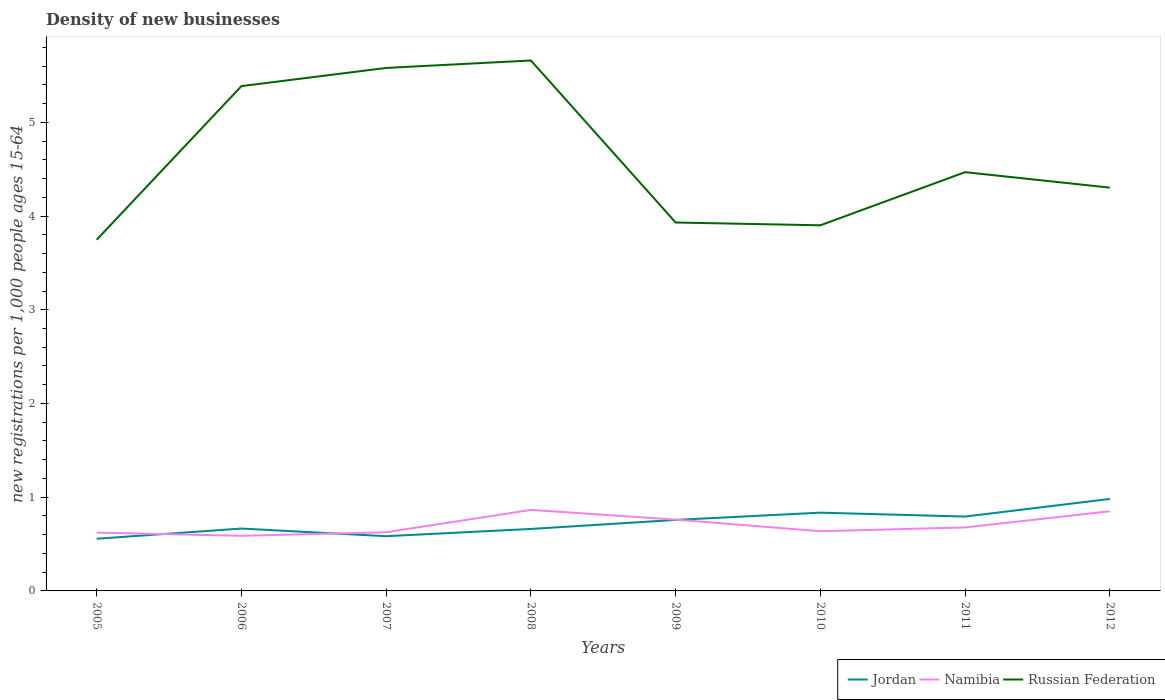Across all years, what is the maximum number of new registrations in Jordan?
Make the answer very short. 0.56. What is the total number of new registrations in Namibia in the graph?
Give a very brief answer. -0.05. What is the difference between the highest and the second highest number of new registrations in Russian Federation?
Offer a terse response. 1.91. Is the number of new registrations in Jordan strictly greater than the number of new registrations in Namibia over the years?
Give a very brief answer. No. How many lines are there?
Provide a short and direct response. 3. Are the values on the major ticks of Y-axis written in scientific E-notation?
Ensure brevity in your answer.  No. Does the graph contain any zero values?
Ensure brevity in your answer.  No. What is the title of the graph?
Give a very brief answer. Density of new businesses. What is the label or title of the Y-axis?
Your response must be concise. New registrations per 1,0 people ages 15-64. What is the new registrations per 1,000 people ages 15-64 of Jordan in 2005?
Your answer should be very brief. 0.56. What is the new registrations per 1,000 people ages 15-64 of Namibia in 2005?
Offer a terse response. 0.62. What is the new registrations per 1,000 people ages 15-64 of Russian Federation in 2005?
Provide a succinct answer. 3.75. What is the new registrations per 1,000 people ages 15-64 of Jordan in 2006?
Your answer should be very brief. 0.67. What is the new registrations per 1,000 people ages 15-64 of Namibia in 2006?
Make the answer very short. 0.59. What is the new registrations per 1,000 people ages 15-64 in Russian Federation in 2006?
Your response must be concise. 5.39. What is the new registrations per 1,000 people ages 15-64 of Jordan in 2007?
Your response must be concise. 0.58. What is the new registrations per 1,000 people ages 15-64 in Namibia in 2007?
Keep it short and to the point. 0.63. What is the new registrations per 1,000 people ages 15-64 in Russian Federation in 2007?
Your answer should be compact. 5.58. What is the new registrations per 1,000 people ages 15-64 in Jordan in 2008?
Provide a succinct answer. 0.66. What is the new registrations per 1,000 people ages 15-64 in Namibia in 2008?
Make the answer very short. 0.86. What is the new registrations per 1,000 people ages 15-64 of Russian Federation in 2008?
Ensure brevity in your answer.  5.66. What is the new registrations per 1,000 people ages 15-64 of Jordan in 2009?
Offer a very short reply. 0.76. What is the new registrations per 1,000 people ages 15-64 of Namibia in 2009?
Give a very brief answer. 0.76. What is the new registrations per 1,000 people ages 15-64 of Russian Federation in 2009?
Provide a succinct answer. 3.93. What is the new registrations per 1,000 people ages 15-64 in Jordan in 2010?
Ensure brevity in your answer.  0.84. What is the new registrations per 1,000 people ages 15-64 in Namibia in 2010?
Keep it short and to the point. 0.64. What is the new registrations per 1,000 people ages 15-64 of Russian Federation in 2010?
Your answer should be compact. 3.9. What is the new registrations per 1,000 people ages 15-64 of Jordan in 2011?
Make the answer very short. 0.79. What is the new registrations per 1,000 people ages 15-64 of Namibia in 2011?
Your response must be concise. 0.68. What is the new registrations per 1,000 people ages 15-64 of Russian Federation in 2011?
Keep it short and to the point. 4.47. What is the new registrations per 1,000 people ages 15-64 of Jordan in 2012?
Provide a succinct answer. 0.98. What is the new registrations per 1,000 people ages 15-64 of Russian Federation in 2012?
Provide a succinct answer. 4.3. Across all years, what is the maximum new registrations per 1,000 people ages 15-64 of Jordan?
Your answer should be very brief. 0.98. Across all years, what is the maximum new registrations per 1,000 people ages 15-64 in Namibia?
Keep it short and to the point. 0.86. Across all years, what is the maximum new registrations per 1,000 people ages 15-64 in Russian Federation?
Ensure brevity in your answer.  5.66. Across all years, what is the minimum new registrations per 1,000 people ages 15-64 of Jordan?
Keep it short and to the point. 0.56. Across all years, what is the minimum new registrations per 1,000 people ages 15-64 of Namibia?
Make the answer very short. 0.59. Across all years, what is the minimum new registrations per 1,000 people ages 15-64 in Russian Federation?
Make the answer very short. 3.75. What is the total new registrations per 1,000 people ages 15-64 in Jordan in the graph?
Provide a succinct answer. 5.83. What is the total new registrations per 1,000 people ages 15-64 of Namibia in the graph?
Offer a terse response. 5.63. What is the total new registrations per 1,000 people ages 15-64 of Russian Federation in the graph?
Make the answer very short. 36.98. What is the difference between the new registrations per 1,000 people ages 15-64 in Jordan in 2005 and that in 2006?
Provide a succinct answer. -0.11. What is the difference between the new registrations per 1,000 people ages 15-64 of Namibia in 2005 and that in 2006?
Keep it short and to the point. 0.03. What is the difference between the new registrations per 1,000 people ages 15-64 of Russian Federation in 2005 and that in 2006?
Make the answer very short. -1.64. What is the difference between the new registrations per 1,000 people ages 15-64 of Jordan in 2005 and that in 2007?
Provide a short and direct response. -0.03. What is the difference between the new registrations per 1,000 people ages 15-64 of Namibia in 2005 and that in 2007?
Offer a terse response. -0. What is the difference between the new registrations per 1,000 people ages 15-64 of Russian Federation in 2005 and that in 2007?
Your answer should be very brief. -1.83. What is the difference between the new registrations per 1,000 people ages 15-64 of Jordan in 2005 and that in 2008?
Make the answer very short. -0.1. What is the difference between the new registrations per 1,000 people ages 15-64 in Namibia in 2005 and that in 2008?
Provide a short and direct response. -0.24. What is the difference between the new registrations per 1,000 people ages 15-64 of Russian Federation in 2005 and that in 2008?
Your answer should be very brief. -1.91. What is the difference between the new registrations per 1,000 people ages 15-64 in Jordan in 2005 and that in 2009?
Offer a very short reply. -0.2. What is the difference between the new registrations per 1,000 people ages 15-64 in Namibia in 2005 and that in 2009?
Offer a very short reply. -0.14. What is the difference between the new registrations per 1,000 people ages 15-64 in Russian Federation in 2005 and that in 2009?
Give a very brief answer. -0.18. What is the difference between the new registrations per 1,000 people ages 15-64 in Jordan in 2005 and that in 2010?
Give a very brief answer. -0.28. What is the difference between the new registrations per 1,000 people ages 15-64 of Namibia in 2005 and that in 2010?
Provide a short and direct response. -0.01. What is the difference between the new registrations per 1,000 people ages 15-64 of Russian Federation in 2005 and that in 2010?
Provide a short and direct response. -0.15. What is the difference between the new registrations per 1,000 people ages 15-64 in Jordan in 2005 and that in 2011?
Give a very brief answer. -0.24. What is the difference between the new registrations per 1,000 people ages 15-64 of Namibia in 2005 and that in 2011?
Give a very brief answer. -0.06. What is the difference between the new registrations per 1,000 people ages 15-64 of Russian Federation in 2005 and that in 2011?
Your response must be concise. -0.72. What is the difference between the new registrations per 1,000 people ages 15-64 of Jordan in 2005 and that in 2012?
Provide a short and direct response. -0.42. What is the difference between the new registrations per 1,000 people ages 15-64 in Namibia in 2005 and that in 2012?
Offer a very short reply. -0.23. What is the difference between the new registrations per 1,000 people ages 15-64 of Russian Federation in 2005 and that in 2012?
Give a very brief answer. -0.56. What is the difference between the new registrations per 1,000 people ages 15-64 in Jordan in 2006 and that in 2007?
Your answer should be very brief. 0.08. What is the difference between the new registrations per 1,000 people ages 15-64 in Namibia in 2006 and that in 2007?
Your answer should be very brief. -0.04. What is the difference between the new registrations per 1,000 people ages 15-64 of Russian Federation in 2006 and that in 2007?
Your answer should be very brief. -0.19. What is the difference between the new registrations per 1,000 people ages 15-64 in Jordan in 2006 and that in 2008?
Provide a short and direct response. 0. What is the difference between the new registrations per 1,000 people ages 15-64 of Namibia in 2006 and that in 2008?
Offer a terse response. -0.28. What is the difference between the new registrations per 1,000 people ages 15-64 in Russian Federation in 2006 and that in 2008?
Ensure brevity in your answer.  -0.27. What is the difference between the new registrations per 1,000 people ages 15-64 in Jordan in 2006 and that in 2009?
Your response must be concise. -0.09. What is the difference between the new registrations per 1,000 people ages 15-64 of Namibia in 2006 and that in 2009?
Give a very brief answer. -0.17. What is the difference between the new registrations per 1,000 people ages 15-64 of Russian Federation in 2006 and that in 2009?
Offer a very short reply. 1.46. What is the difference between the new registrations per 1,000 people ages 15-64 in Jordan in 2006 and that in 2010?
Make the answer very short. -0.17. What is the difference between the new registrations per 1,000 people ages 15-64 of Namibia in 2006 and that in 2010?
Your answer should be very brief. -0.05. What is the difference between the new registrations per 1,000 people ages 15-64 in Russian Federation in 2006 and that in 2010?
Provide a short and direct response. 1.49. What is the difference between the new registrations per 1,000 people ages 15-64 in Jordan in 2006 and that in 2011?
Your answer should be very brief. -0.13. What is the difference between the new registrations per 1,000 people ages 15-64 in Namibia in 2006 and that in 2011?
Make the answer very short. -0.09. What is the difference between the new registrations per 1,000 people ages 15-64 in Russian Federation in 2006 and that in 2011?
Give a very brief answer. 0.92. What is the difference between the new registrations per 1,000 people ages 15-64 in Jordan in 2006 and that in 2012?
Make the answer very short. -0.32. What is the difference between the new registrations per 1,000 people ages 15-64 of Namibia in 2006 and that in 2012?
Give a very brief answer. -0.26. What is the difference between the new registrations per 1,000 people ages 15-64 of Russian Federation in 2006 and that in 2012?
Provide a short and direct response. 1.08. What is the difference between the new registrations per 1,000 people ages 15-64 in Jordan in 2007 and that in 2008?
Give a very brief answer. -0.08. What is the difference between the new registrations per 1,000 people ages 15-64 of Namibia in 2007 and that in 2008?
Make the answer very short. -0.24. What is the difference between the new registrations per 1,000 people ages 15-64 in Russian Federation in 2007 and that in 2008?
Offer a very short reply. -0.08. What is the difference between the new registrations per 1,000 people ages 15-64 of Jordan in 2007 and that in 2009?
Provide a succinct answer. -0.17. What is the difference between the new registrations per 1,000 people ages 15-64 in Namibia in 2007 and that in 2009?
Give a very brief answer. -0.13. What is the difference between the new registrations per 1,000 people ages 15-64 of Russian Federation in 2007 and that in 2009?
Make the answer very short. 1.65. What is the difference between the new registrations per 1,000 people ages 15-64 of Jordan in 2007 and that in 2010?
Provide a short and direct response. -0.25. What is the difference between the new registrations per 1,000 people ages 15-64 in Namibia in 2007 and that in 2010?
Give a very brief answer. -0.01. What is the difference between the new registrations per 1,000 people ages 15-64 in Russian Federation in 2007 and that in 2010?
Offer a terse response. 1.68. What is the difference between the new registrations per 1,000 people ages 15-64 of Jordan in 2007 and that in 2011?
Ensure brevity in your answer.  -0.21. What is the difference between the new registrations per 1,000 people ages 15-64 of Namibia in 2007 and that in 2011?
Provide a succinct answer. -0.05. What is the difference between the new registrations per 1,000 people ages 15-64 in Russian Federation in 2007 and that in 2011?
Your answer should be compact. 1.11. What is the difference between the new registrations per 1,000 people ages 15-64 of Jordan in 2007 and that in 2012?
Give a very brief answer. -0.4. What is the difference between the new registrations per 1,000 people ages 15-64 of Namibia in 2007 and that in 2012?
Offer a very short reply. -0.22. What is the difference between the new registrations per 1,000 people ages 15-64 of Russian Federation in 2007 and that in 2012?
Your answer should be very brief. 1.28. What is the difference between the new registrations per 1,000 people ages 15-64 of Jordan in 2008 and that in 2009?
Keep it short and to the point. -0.1. What is the difference between the new registrations per 1,000 people ages 15-64 of Namibia in 2008 and that in 2009?
Keep it short and to the point. 0.1. What is the difference between the new registrations per 1,000 people ages 15-64 in Russian Federation in 2008 and that in 2009?
Your answer should be compact. 1.73. What is the difference between the new registrations per 1,000 people ages 15-64 in Jordan in 2008 and that in 2010?
Offer a very short reply. -0.17. What is the difference between the new registrations per 1,000 people ages 15-64 in Namibia in 2008 and that in 2010?
Make the answer very short. 0.23. What is the difference between the new registrations per 1,000 people ages 15-64 of Russian Federation in 2008 and that in 2010?
Provide a short and direct response. 1.76. What is the difference between the new registrations per 1,000 people ages 15-64 in Jordan in 2008 and that in 2011?
Ensure brevity in your answer.  -0.13. What is the difference between the new registrations per 1,000 people ages 15-64 in Namibia in 2008 and that in 2011?
Ensure brevity in your answer.  0.19. What is the difference between the new registrations per 1,000 people ages 15-64 of Russian Federation in 2008 and that in 2011?
Provide a short and direct response. 1.19. What is the difference between the new registrations per 1,000 people ages 15-64 in Jordan in 2008 and that in 2012?
Offer a very short reply. -0.32. What is the difference between the new registrations per 1,000 people ages 15-64 in Namibia in 2008 and that in 2012?
Offer a terse response. 0.01. What is the difference between the new registrations per 1,000 people ages 15-64 in Russian Federation in 2008 and that in 2012?
Offer a terse response. 1.36. What is the difference between the new registrations per 1,000 people ages 15-64 in Jordan in 2009 and that in 2010?
Provide a short and direct response. -0.08. What is the difference between the new registrations per 1,000 people ages 15-64 in Namibia in 2009 and that in 2010?
Keep it short and to the point. 0.12. What is the difference between the new registrations per 1,000 people ages 15-64 in Russian Federation in 2009 and that in 2010?
Make the answer very short. 0.03. What is the difference between the new registrations per 1,000 people ages 15-64 of Jordan in 2009 and that in 2011?
Offer a terse response. -0.04. What is the difference between the new registrations per 1,000 people ages 15-64 in Namibia in 2009 and that in 2011?
Your answer should be compact. 0.08. What is the difference between the new registrations per 1,000 people ages 15-64 of Russian Federation in 2009 and that in 2011?
Ensure brevity in your answer.  -0.54. What is the difference between the new registrations per 1,000 people ages 15-64 of Jordan in 2009 and that in 2012?
Give a very brief answer. -0.22. What is the difference between the new registrations per 1,000 people ages 15-64 in Namibia in 2009 and that in 2012?
Provide a succinct answer. -0.09. What is the difference between the new registrations per 1,000 people ages 15-64 in Russian Federation in 2009 and that in 2012?
Your answer should be very brief. -0.37. What is the difference between the new registrations per 1,000 people ages 15-64 in Jordan in 2010 and that in 2011?
Give a very brief answer. 0.04. What is the difference between the new registrations per 1,000 people ages 15-64 of Namibia in 2010 and that in 2011?
Your answer should be compact. -0.04. What is the difference between the new registrations per 1,000 people ages 15-64 in Russian Federation in 2010 and that in 2011?
Ensure brevity in your answer.  -0.57. What is the difference between the new registrations per 1,000 people ages 15-64 in Jordan in 2010 and that in 2012?
Ensure brevity in your answer.  -0.15. What is the difference between the new registrations per 1,000 people ages 15-64 of Namibia in 2010 and that in 2012?
Offer a terse response. -0.21. What is the difference between the new registrations per 1,000 people ages 15-64 in Russian Federation in 2010 and that in 2012?
Give a very brief answer. -0.4. What is the difference between the new registrations per 1,000 people ages 15-64 of Jordan in 2011 and that in 2012?
Give a very brief answer. -0.19. What is the difference between the new registrations per 1,000 people ages 15-64 in Namibia in 2011 and that in 2012?
Make the answer very short. -0.17. What is the difference between the new registrations per 1,000 people ages 15-64 in Russian Federation in 2011 and that in 2012?
Make the answer very short. 0.17. What is the difference between the new registrations per 1,000 people ages 15-64 in Jordan in 2005 and the new registrations per 1,000 people ages 15-64 in Namibia in 2006?
Give a very brief answer. -0.03. What is the difference between the new registrations per 1,000 people ages 15-64 in Jordan in 2005 and the new registrations per 1,000 people ages 15-64 in Russian Federation in 2006?
Ensure brevity in your answer.  -4.83. What is the difference between the new registrations per 1,000 people ages 15-64 of Namibia in 2005 and the new registrations per 1,000 people ages 15-64 of Russian Federation in 2006?
Offer a terse response. -4.76. What is the difference between the new registrations per 1,000 people ages 15-64 in Jordan in 2005 and the new registrations per 1,000 people ages 15-64 in Namibia in 2007?
Your answer should be compact. -0.07. What is the difference between the new registrations per 1,000 people ages 15-64 of Jordan in 2005 and the new registrations per 1,000 people ages 15-64 of Russian Federation in 2007?
Your response must be concise. -5.02. What is the difference between the new registrations per 1,000 people ages 15-64 of Namibia in 2005 and the new registrations per 1,000 people ages 15-64 of Russian Federation in 2007?
Provide a short and direct response. -4.96. What is the difference between the new registrations per 1,000 people ages 15-64 of Jordan in 2005 and the new registrations per 1,000 people ages 15-64 of Namibia in 2008?
Keep it short and to the point. -0.31. What is the difference between the new registrations per 1,000 people ages 15-64 in Jordan in 2005 and the new registrations per 1,000 people ages 15-64 in Russian Federation in 2008?
Provide a succinct answer. -5.1. What is the difference between the new registrations per 1,000 people ages 15-64 of Namibia in 2005 and the new registrations per 1,000 people ages 15-64 of Russian Federation in 2008?
Provide a succinct answer. -5.04. What is the difference between the new registrations per 1,000 people ages 15-64 in Jordan in 2005 and the new registrations per 1,000 people ages 15-64 in Namibia in 2009?
Your response must be concise. -0.2. What is the difference between the new registrations per 1,000 people ages 15-64 of Jordan in 2005 and the new registrations per 1,000 people ages 15-64 of Russian Federation in 2009?
Keep it short and to the point. -3.37. What is the difference between the new registrations per 1,000 people ages 15-64 of Namibia in 2005 and the new registrations per 1,000 people ages 15-64 of Russian Federation in 2009?
Keep it short and to the point. -3.31. What is the difference between the new registrations per 1,000 people ages 15-64 of Jordan in 2005 and the new registrations per 1,000 people ages 15-64 of Namibia in 2010?
Keep it short and to the point. -0.08. What is the difference between the new registrations per 1,000 people ages 15-64 of Jordan in 2005 and the new registrations per 1,000 people ages 15-64 of Russian Federation in 2010?
Keep it short and to the point. -3.34. What is the difference between the new registrations per 1,000 people ages 15-64 in Namibia in 2005 and the new registrations per 1,000 people ages 15-64 in Russian Federation in 2010?
Give a very brief answer. -3.28. What is the difference between the new registrations per 1,000 people ages 15-64 of Jordan in 2005 and the new registrations per 1,000 people ages 15-64 of Namibia in 2011?
Your answer should be compact. -0.12. What is the difference between the new registrations per 1,000 people ages 15-64 in Jordan in 2005 and the new registrations per 1,000 people ages 15-64 in Russian Federation in 2011?
Offer a very short reply. -3.91. What is the difference between the new registrations per 1,000 people ages 15-64 in Namibia in 2005 and the new registrations per 1,000 people ages 15-64 in Russian Federation in 2011?
Give a very brief answer. -3.85. What is the difference between the new registrations per 1,000 people ages 15-64 of Jordan in 2005 and the new registrations per 1,000 people ages 15-64 of Namibia in 2012?
Offer a terse response. -0.29. What is the difference between the new registrations per 1,000 people ages 15-64 in Jordan in 2005 and the new registrations per 1,000 people ages 15-64 in Russian Federation in 2012?
Offer a terse response. -3.75. What is the difference between the new registrations per 1,000 people ages 15-64 in Namibia in 2005 and the new registrations per 1,000 people ages 15-64 in Russian Federation in 2012?
Give a very brief answer. -3.68. What is the difference between the new registrations per 1,000 people ages 15-64 of Jordan in 2006 and the new registrations per 1,000 people ages 15-64 of Namibia in 2007?
Your answer should be very brief. 0.04. What is the difference between the new registrations per 1,000 people ages 15-64 of Jordan in 2006 and the new registrations per 1,000 people ages 15-64 of Russian Federation in 2007?
Ensure brevity in your answer.  -4.91. What is the difference between the new registrations per 1,000 people ages 15-64 of Namibia in 2006 and the new registrations per 1,000 people ages 15-64 of Russian Federation in 2007?
Provide a short and direct response. -4.99. What is the difference between the new registrations per 1,000 people ages 15-64 in Jordan in 2006 and the new registrations per 1,000 people ages 15-64 in Namibia in 2008?
Provide a short and direct response. -0.2. What is the difference between the new registrations per 1,000 people ages 15-64 in Jordan in 2006 and the new registrations per 1,000 people ages 15-64 in Russian Federation in 2008?
Offer a terse response. -4.99. What is the difference between the new registrations per 1,000 people ages 15-64 in Namibia in 2006 and the new registrations per 1,000 people ages 15-64 in Russian Federation in 2008?
Ensure brevity in your answer.  -5.07. What is the difference between the new registrations per 1,000 people ages 15-64 in Jordan in 2006 and the new registrations per 1,000 people ages 15-64 in Namibia in 2009?
Your answer should be compact. -0.1. What is the difference between the new registrations per 1,000 people ages 15-64 of Jordan in 2006 and the new registrations per 1,000 people ages 15-64 of Russian Federation in 2009?
Offer a terse response. -3.27. What is the difference between the new registrations per 1,000 people ages 15-64 of Namibia in 2006 and the new registrations per 1,000 people ages 15-64 of Russian Federation in 2009?
Provide a succinct answer. -3.34. What is the difference between the new registrations per 1,000 people ages 15-64 in Jordan in 2006 and the new registrations per 1,000 people ages 15-64 in Namibia in 2010?
Provide a succinct answer. 0.03. What is the difference between the new registrations per 1,000 people ages 15-64 of Jordan in 2006 and the new registrations per 1,000 people ages 15-64 of Russian Federation in 2010?
Ensure brevity in your answer.  -3.24. What is the difference between the new registrations per 1,000 people ages 15-64 of Namibia in 2006 and the new registrations per 1,000 people ages 15-64 of Russian Federation in 2010?
Keep it short and to the point. -3.31. What is the difference between the new registrations per 1,000 people ages 15-64 in Jordan in 2006 and the new registrations per 1,000 people ages 15-64 in Namibia in 2011?
Keep it short and to the point. -0.01. What is the difference between the new registrations per 1,000 people ages 15-64 in Jordan in 2006 and the new registrations per 1,000 people ages 15-64 in Russian Federation in 2011?
Your answer should be very brief. -3.8. What is the difference between the new registrations per 1,000 people ages 15-64 in Namibia in 2006 and the new registrations per 1,000 people ages 15-64 in Russian Federation in 2011?
Ensure brevity in your answer.  -3.88. What is the difference between the new registrations per 1,000 people ages 15-64 in Jordan in 2006 and the new registrations per 1,000 people ages 15-64 in Namibia in 2012?
Provide a short and direct response. -0.18. What is the difference between the new registrations per 1,000 people ages 15-64 of Jordan in 2006 and the new registrations per 1,000 people ages 15-64 of Russian Federation in 2012?
Your answer should be compact. -3.64. What is the difference between the new registrations per 1,000 people ages 15-64 of Namibia in 2006 and the new registrations per 1,000 people ages 15-64 of Russian Federation in 2012?
Provide a short and direct response. -3.71. What is the difference between the new registrations per 1,000 people ages 15-64 of Jordan in 2007 and the new registrations per 1,000 people ages 15-64 of Namibia in 2008?
Offer a terse response. -0.28. What is the difference between the new registrations per 1,000 people ages 15-64 of Jordan in 2007 and the new registrations per 1,000 people ages 15-64 of Russian Federation in 2008?
Make the answer very short. -5.08. What is the difference between the new registrations per 1,000 people ages 15-64 in Namibia in 2007 and the new registrations per 1,000 people ages 15-64 in Russian Federation in 2008?
Keep it short and to the point. -5.03. What is the difference between the new registrations per 1,000 people ages 15-64 of Jordan in 2007 and the new registrations per 1,000 people ages 15-64 of Namibia in 2009?
Give a very brief answer. -0.18. What is the difference between the new registrations per 1,000 people ages 15-64 in Jordan in 2007 and the new registrations per 1,000 people ages 15-64 in Russian Federation in 2009?
Offer a terse response. -3.35. What is the difference between the new registrations per 1,000 people ages 15-64 in Namibia in 2007 and the new registrations per 1,000 people ages 15-64 in Russian Federation in 2009?
Offer a very short reply. -3.3. What is the difference between the new registrations per 1,000 people ages 15-64 of Jordan in 2007 and the new registrations per 1,000 people ages 15-64 of Namibia in 2010?
Offer a very short reply. -0.05. What is the difference between the new registrations per 1,000 people ages 15-64 of Jordan in 2007 and the new registrations per 1,000 people ages 15-64 of Russian Federation in 2010?
Keep it short and to the point. -3.32. What is the difference between the new registrations per 1,000 people ages 15-64 of Namibia in 2007 and the new registrations per 1,000 people ages 15-64 of Russian Federation in 2010?
Provide a short and direct response. -3.27. What is the difference between the new registrations per 1,000 people ages 15-64 of Jordan in 2007 and the new registrations per 1,000 people ages 15-64 of Namibia in 2011?
Offer a terse response. -0.09. What is the difference between the new registrations per 1,000 people ages 15-64 in Jordan in 2007 and the new registrations per 1,000 people ages 15-64 in Russian Federation in 2011?
Offer a terse response. -3.88. What is the difference between the new registrations per 1,000 people ages 15-64 of Namibia in 2007 and the new registrations per 1,000 people ages 15-64 of Russian Federation in 2011?
Your answer should be compact. -3.84. What is the difference between the new registrations per 1,000 people ages 15-64 in Jordan in 2007 and the new registrations per 1,000 people ages 15-64 in Namibia in 2012?
Offer a terse response. -0.27. What is the difference between the new registrations per 1,000 people ages 15-64 in Jordan in 2007 and the new registrations per 1,000 people ages 15-64 in Russian Federation in 2012?
Ensure brevity in your answer.  -3.72. What is the difference between the new registrations per 1,000 people ages 15-64 of Namibia in 2007 and the new registrations per 1,000 people ages 15-64 of Russian Federation in 2012?
Ensure brevity in your answer.  -3.68. What is the difference between the new registrations per 1,000 people ages 15-64 in Jordan in 2008 and the new registrations per 1,000 people ages 15-64 in Namibia in 2009?
Give a very brief answer. -0.1. What is the difference between the new registrations per 1,000 people ages 15-64 of Jordan in 2008 and the new registrations per 1,000 people ages 15-64 of Russian Federation in 2009?
Keep it short and to the point. -3.27. What is the difference between the new registrations per 1,000 people ages 15-64 in Namibia in 2008 and the new registrations per 1,000 people ages 15-64 in Russian Federation in 2009?
Provide a short and direct response. -3.07. What is the difference between the new registrations per 1,000 people ages 15-64 in Jordan in 2008 and the new registrations per 1,000 people ages 15-64 in Namibia in 2010?
Ensure brevity in your answer.  0.02. What is the difference between the new registrations per 1,000 people ages 15-64 in Jordan in 2008 and the new registrations per 1,000 people ages 15-64 in Russian Federation in 2010?
Make the answer very short. -3.24. What is the difference between the new registrations per 1,000 people ages 15-64 of Namibia in 2008 and the new registrations per 1,000 people ages 15-64 of Russian Federation in 2010?
Offer a very short reply. -3.04. What is the difference between the new registrations per 1,000 people ages 15-64 in Jordan in 2008 and the new registrations per 1,000 people ages 15-64 in Namibia in 2011?
Ensure brevity in your answer.  -0.02. What is the difference between the new registrations per 1,000 people ages 15-64 of Jordan in 2008 and the new registrations per 1,000 people ages 15-64 of Russian Federation in 2011?
Offer a terse response. -3.81. What is the difference between the new registrations per 1,000 people ages 15-64 of Namibia in 2008 and the new registrations per 1,000 people ages 15-64 of Russian Federation in 2011?
Give a very brief answer. -3.6. What is the difference between the new registrations per 1,000 people ages 15-64 of Jordan in 2008 and the new registrations per 1,000 people ages 15-64 of Namibia in 2012?
Keep it short and to the point. -0.19. What is the difference between the new registrations per 1,000 people ages 15-64 in Jordan in 2008 and the new registrations per 1,000 people ages 15-64 in Russian Federation in 2012?
Make the answer very short. -3.64. What is the difference between the new registrations per 1,000 people ages 15-64 of Namibia in 2008 and the new registrations per 1,000 people ages 15-64 of Russian Federation in 2012?
Your answer should be compact. -3.44. What is the difference between the new registrations per 1,000 people ages 15-64 of Jordan in 2009 and the new registrations per 1,000 people ages 15-64 of Namibia in 2010?
Your response must be concise. 0.12. What is the difference between the new registrations per 1,000 people ages 15-64 in Jordan in 2009 and the new registrations per 1,000 people ages 15-64 in Russian Federation in 2010?
Ensure brevity in your answer.  -3.14. What is the difference between the new registrations per 1,000 people ages 15-64 of Namibia in 2009 and the new registrations per 1,000 people ages 15-64 of Russian Federation in 2010?
Give a very brief answer. -3.14. What is the difference between the new registrations per 1,000 people ages 15-64 in Jordan in 2009 and the new registrations per 1,000 people ages 15-64 in Namibia in 2011?
Make the answer very short. 0.08. What is the difference between the new registrations per 1,000 people ages 15-64 of Jordan in 2009 and the new registrations per 1,000 people ages 15-64 of Russian Federation in 2011?
Your answer should be compact. -3.71. What is the difference between the new registrations per 1,000 people ages 15-64 of Namibia in 2009 and the new registrations per 1,000 people ages 15-64 of Russian Federation in 2011?
Make the answer very short. -3.71. What is the difference between the new registrations per 1,000 people ages 15-64 in Jordan in 2009 and the new registrations per 1,000 people ages 15-64 in Namibia in 2012?
Keep it short and to the point. -0.09. What is the difference between the new registrations per 1,000 people ages 15-64 in Jordan in 2009 and the new registrations per 1,000 people ages 15-64 in Russian Federation in 2012?
Offer a very short reply. -3.55. What is the difference between the new registrations per 1,000 people ages 15-64 of Namibia in 2009 and the new registrations per 1,000 people ages 15-64 of Russian Federation in 2012?
Offer a terse response. -3.54. What is the difference between the new registrations per 1,000 people ages 15-64 in Jordan in 2010 and the new registrations per 1,000 people ages 15-64 in Namibia in 2011?
Provide a short and direct response. 0.16. What is the difference between the new registrations per 1,000 people ages 15-64 of Jordan in 2010 and the new registrations per 1,000 people ages 15-64 of Russian Federation in 2011?
Make the answer very short. -3.63. What is the difference between the new registrations per 1,000 people ages 15-64 in Namibia in 2010 and the new registrations per 1,000 people ages 15-64 in Russian Federation in 2011?
Your response must be concise. -3.83. What is the difference between the new registrations per 1,000 people ages 15-64 in Jordan in 2010 and the new registrations per 1,000 people ages 15-64 in Namibia in 2012?
Offer a very short reply. -0.01. What is the difference between the new registrations per 1,000 people ages 15-64 of Jordan in 2010 and the new registrations per 1,000 people ages 15-64 of Russian Federation in 2012?
Ensure brevity in your answer.  -3.47. What is the difference between the new registrations per 1,000 people ages 15-64 of Namibia in 2010 and the new registrations per 1,000 people ages 15-64 of Russian Federation in 2012?
Your answer should be compact. -3.67. What is the difference between the new registrations per 1,000 people ages 15-64 in Jordan in 2011 and the new registrations per 1,000 people ages 15-64 in Namibia in 2012?
Ensure brevity in your answer.  -0.06. What is the difference between the new registrations per 1,000 people ages 15-64 of Jordan in 2011 and the new registrations per 1,000 people ages 15-64 of Russian Federation in 2012?
Your response must be concise. -3.51. What is the difference between the new registrations per 1,000 people ages 15-64 of Namibia in 2011 and the new registrations per 1,000 people ages 15-64 of Russian Federation in 2012?
Give a very brief answer. -3.63. What is the average new registrations per 1,000 people ages 15-64 in Jordan per year?
Offer a terse response. 0.73. What is the average new registrations per 1,000 people ages 15-64 in Namibia per year?
Your response must be concise. 0.7. What is the average new registrations per 1,000 people ages 15-64 of Russian Federation per year?
Your answer should be very brief. 4.62. In the year 2005, what is the difference between the new registrations per 1,000 people ages 15-64 in Jordan and new registrations per 1,000 people ages 15-64 in Namibia?
Make the answer very short. -0.07. In the year 2005, what is the difference between the new registrations per 1,000 people ages 15-64 of Jordan and new registrations per 1,000 people ages 15-64 of Russian Federation?
Keep it short and to the point. -3.19. In the year 2005, what is the difference between the new registrations per 1,000 people ages 15-64 in Namibia and new registrations per 1,000 people ages 15-64 in Russian Federation?
Ensure brevity in your answer.  -3.13. In the year 2006, what is the difference between the new registrations per 1,000 people ages 15-64 in Jordan and new registrations per 1,000 people ages 15-64 in Namibia?
Offer a very short reply. 0.08. In the year 2006, what is the difference between the new registrations per 1,000 people ages 15-64 in Jordan and new registrations per 1,000 people ages 15-64 in Russian Federation?
Your answer should be very brief. -4.72. In the year 2006, what is the difference between the new registrations per 1,000 people ages 15-64 in Namibia and new registrations per 1,000 people ages 15-64 in Russian Federation?
Provide a succinct answer. -4.8. In the year 2007, what is the difference between the new registrations per 1,000 people ages 15-64 of Jordan and new registrations per 1,000 people ages 15-64 of Namibia?
Provide a succinct answer. -0.04. In the year 2007, what is the difference between the new registrations per 1,000 people ages 15-64 in Jordan and new registrations per 1,000 people ages 15-64 in Russian Federation?
Offer a very short reply. -5. In the year 2007, what is the difference between the new registrations per 1,000 people ages 15-64 in Namibia and new registrations per 1,000 people ages 15-64 in Russian Federation?
Provide a short and direct response. -4.95. In the year 2008, what is the difference between the new registrations per 1,000 people ages 15-64 of Jordan and new registrations per 1,000 people ages 15-64 of Namibia?
Keep it short and to the point. -0.2. In the year 2008, what is the difference between the new registrations per 1,000 people ages 15-64 in Jordan and new registrations per 1,000 people ages 15-64 in Russian Federation?
Your answer should be very brief. -5. In the year 2008, what is the difference between the new registrations per 1,000 people ages 15-64 of Namibia and new registrations per 1,000 people ages 15-64 of Russian Federation?
Provide a succinct answer. -4.79. In the year 2009, what is the difference between the new registrations per 1,000 people ages 15-64 in Jordan and new registrations per 1,000 people ages 15-64 in Namibia?
Your response must be concise. -0. In the year 2009, what is the difference between the new registrations per 1,000 people ages 15-64 in Jordan and new registrations per 1,000 people ages 15-64 in Russian Federation?
Offer a very short reply. -3.17. In the year 2009, what is the difference between the new registrations per 1,000 people ages 15-64 of Namibia and new registrations per 1,000 people ages 15-64 of Russian Federation?
Your answer should be very brief. -3.17. In the year 2010, what is the difference between the new registrations per 1,000 people ages 15-64 of Jordan and new registrations per 1,000 people ages 15-64 of Namibia?
Provide a succinct answer. 0.2. In the year 2010, what is the difference between the new registrations per 1,000 people ages 15-64 in Jordan and new registrations per 1,000 people ages 15-64 in Russian Federation?
Offer a terse response. -3.07. In the year 2010, what is the difference between the new registrations per 1,000 people ages 15-64 of Namibia and new registrations per 1,000 people ages 15-64 of Russian Federation?
Make the answer very short. -3.26. In the year 2011, what is the difference between the new registrations per 1,000 people ages 15-64 in Jordan and new registrations per 1,000 people ages 15-64 in Namibia?
Offer a terse response. 0.12. In the year 2011, what is the difference between the new registrations per 1,000 people ages 15-64 in Jordan and new registrations per 1,000 people ages 15-64 in Russian Federation?
Your response must be concise. -3.67. In the year 2011, what is the difference between the new registrations per 1,000 people ages 15-64 of Namibia and new registrations per 1,000 people ages 15-64 of Russian Federation?
Provide a succinct answer. -3.79. In the year 2012, what is the difference between the new registrations per 1,000 people ages 15-64 of Jordan and new registrations per 1,000 people ages 15-64 of Namibia?
Your answer should be very brief. 0.13. In the year 2012, what is the difference between the new registrations per 1,000 people ages 15-64 in Jordan and new registrations per 1,000 people ages 15-64 in Russian Federation?
Provide a short and direct response. -3.32. In the year 2012, what is the difference between the new registrations per 1,000 people ages 15-64 in Namibia and new registrations per 1,000 people ages 15-64 in Russian Federation?
Your response must be concise. -3.45. What is the ratio of the new registrations per 1,000 people ages 15-64 of Jordan in 2005 to that in 2006?
Your answer should be compact. 0.84. What is the ratio of the new registrations per 1,000 people ages 15-64 in Namibia in 2005 to that in 2006?
Keep it short and to the point. 1.06. What is the ratio of the new registrations per 1,000 people ages 15-64 of Russian Federation in 2005 to that in 2006?
Give a very brief answer. 0.7. What is the ratio of the new registrations per 1,000 people ages 15-64 in Jordan in 2005 to that in 2007?
Provide a succinct answer. 0.95. What is the ratio of the new registrations per 1,000 people ages 15-64 of Namibia in 2005 to that in 2007?
Offer a terse response. 0.99. What is the ratio of the new registrations per 1,000 people ages 15-64 of Russian Federation in 2005 to that in 2007?
Offer a very short reply. 0.67. What is the ratio of the new registrations per 1,000 people ages 15-64 of Jordan in 2005 to that in 2008?
Keep it short and to the point. 0.84. What is the ratio of the new registrations per 1,000 people ages 15-64 of Namibia in 2005 to that in 2008?
Provide a succinct answer. 0.72. What is the ratio of the new registrations per 1,000 people ages 15-64 in Russian Federation in 2005 to that in 2008?
Offer a very short reply. 0.66. What is the ratio of the new registrations per 1,000 people ages 15-64 of Jordan in 2005 to that in 2009?
Give a very brief answer. 0.73. What is the ratio of the new registrations per 1,000 people ages 15-64 of Namibia in 2005 to that in 2009?
Offer a very short reply. 0.82. What is the ratio of the new registrations per 1,000 people ages 15-64 in Russian Federation in 2005 to that in 2009?
Offer a very short reply. 0.95. What is the ratio of the new registrations per 1,000 people ages 15-64 in Namibia in 2005 to that in 2010?
Provide a succinct answer. 0.98. What is the ratio of the new registrations per 1,000 people ages 15-64 of Russian Federation in 2005 to that in 2010?
Provide a succinct answer. 0.96. What is the ratio of the new registrations per 1,000 people ages 15-64 of Jordan in 2005 to that in 2011?
Offer a terse response. 0.7. What is the ratio of the new registrations per 1,000 people ages 15-64 of Namibia in 2005 to that in 2011?
Your response must be concise. 0.92. What is the ratio of the new registrations per 1,000 people ages 15-64 in Russian Federation in 2005 to that in 2011?
Your response must be concise. 0.84. What is the ratio of the new registrations per 1,000 people ages 15-64 of Jordan in 2005 to that in 2012?
Your answer should be compact. 0.57. What is the ratio of the new registrations per 1,000 people ages 15-64 of Namibia in 2005 to that in 2012?
Make the answer very short. 0.73. What is the ratio of the new registrations per 1,000 people ages 15-64 of Russian Federation in 2005 to that in 2012?
Give a very brief answer. 0.87. What is the ratio of the new registrations per 1,000 people ages 15-64 in Jordan in 2006 to that in 2007?
Your response must be concise. 1.14. What is the ratio of the new registrations per 1,000 people ages 15-64 of Namibia in 2006 to that in 2007?
Offer a very short reply. 0.94. What is the ratio of the new registrations per 1,000 people ages 15-64 in Russian Federation in 2006 to that in 2007?
Keep it short and to the point. 0.97. What is the ratio of the new registrations per 1,000 people ages 15-64 of Jordan in 2006 to that in 2008?
Your response must be concise. 1.01. What is the ratio of the new registrations per 1,000 people ages 15-64 in Namibia in 2006 to that in 2008?
Offer a terse response. 0.68. What is the ratio of the new registrations per 1,000 people ages 15-64 in Russian Federation in 2006 to that in 2008?
Make the answer very short. 0.95. What is the ratio of the new registrations per 1,000 people ages 15-64 in Jordan in 2006 to that in 2009?
Your answer should be compact. 0.88. What is the ratio of the new registrations per 1,000 people ages 15-64 in Namibia in 2006 to that in 2009?
Your response must be concise. 0.77. What is the ratio of the new registrations per 1,000 people ages 15-64 of Russian Federation in 2006 to that in 2009?
Provide a short and direct response. 1.37. What is the ratio of the new registrations per 1,000 people ages 15-64 of Jordan in 2006 to that in 2010?
Your answer should be compact. 0.8. What is the ratio of the new registrations per 1,000 people ages 15-64 of Namibia in 2006 to that in 2010?
Your response must be concise. 0.92. What is the ratio of the new registrations per 1,000 people ages 15-64 of Russian Federation in 2006 to that in 2010?
Your answer should be very brief. 1.38. What is the ratio of the new registrations per 1,000 people ages 15-64 of Jordan in 2006 to that in 2011?
Your response must be concise. 0.84. What is the ratio of the new registrations per 1,000 people ages 15-64 in Namibia in 2006 to that in 2011?
Provide a succinct answer. 0.87. What is the ratio of the new registrations per 1,000 people ages 15-64 of Russian Federation in 2006 to that in 2011?
Your response must be concise. 1.21. What is the ratio of the new registrations per 1,000 people ages 15-64 of Jordan in 2006 to that in 2012?
Keep it short and to the point. 0.68. What is the ratio of the new registrations per 1,000 people ages 15-64 in Namibia in 2006 to that in 2012?
Provide a succinct answer. 0.69. What is the ratio of the new registrations per 1,000 people ages 15-64 in Russian Federation in 2006 to that in 2012?
Your response must be concise. 1.25. What is the ratio of the new registrations per 1,000 people ages 15-64 in Jordan in 2007 to that in 2008?
Ensure brevity in your answer.  0.88. What is the ratio of the new registrations per 1,000 people ages 15-64 in Namibia in 2007 to that in 2008?
Offer a very short reply. 0.72. What is the ratio of the new registrations per 1,000 people ages 15-64 of Russian Federation in 2007 to that in 2008?
Your answer should be very brief. 0.99. What is the ratio of the new registrations per 1,000 people ages 15-64 in Jordan in 2007 to that in 2009?
Ensure brevity in your answer.  0.77. What is the ratio of the new registrations per 1,000 people ages 15-64 in Namibia in 2007 to that in 2009?
Make the answer very short. 0.82. What is the ratio of the new registrations per 1,000 people ages 15-64 of Russian Federation in 2007 to that in 2009?
Give a very brief answer. 1.42. What is the ratio of the new registrations per 1,000 people ages 15-64 of Jordan in 2007 to that in 2010?
Your answer should be compact. 0.7. What is the ratio of the new registrations per 1,000 people ages 15-64 in Namibia in 2007 to that in 2010?
Make the answer very short. 0.98. What is the ratio of the new registrations per 1,000 people ages 15-64 of Russian Federation in 2007 to that in 2010?
Your answer should be compact. 1.43. What is the ratio of the new registrations per 1,000 people ages 15-64 of Jordan in 2007 to that in 2011?
Your answer should be very brief. 0.74. What is the ratio of the new registrations per 1,000 people ages 15-64 in Namibia in 2007 to that in 2011?
Keep it short and to the point. 0.92. What is the ratio of the new registrations per 1,000 people ages 15-64 of Russian Federation in 2007 to that in 2011?
Offer a very short reply. 1.25. What is the ratio of the new registrations per 1,000 people ages 15-64 of Jordan in 2007 to that in 2012?
Keep it short and to the point. 0.59. What is the ratio of the new registrations per 1,000 people ages 15-64 of Namibia in 2007 to that in 2012?
Provide a short and direct response. 0.74. What is the ratio of the new registrations per 1,000 people ages 15-64 in Russian Federation in 2007 to that in 2012?
Offer a very short reply. 1.3. What is the ratio of the new registrations per 1,000 people ages 15-64 of Jordan in 2008 to that in 2009?
Offer a terse response. 0.87. What is the ratio of the new registrations per 1,000 people ages 15-64 of Namibia in 2008 to that in 2009?
Provide a short and direct response. 1.14. What is the ratio of the new registrations per 1,000 people ages 15-64 in Russian Federation in 2008 to that in 2009?
Provide a short and direct response. 1.44. What is the ratio of the new registrations per 1,000 people ages 15-64 in Jordan in 2008 to that in 2010?
Keep it short and to the point. 0.79. What is the ratio of the new registrations per 1,000 people ages 15-64 of Namibia in 2008 to that in 2010?
Give a very brief answer. 1.36. What is the ratio of the new registrations per 1,000 people ages 15-64 of Russian Federation in 2008 to that in 2010?
Your response must be concise. 1.45. What is the ratio of the new registrations per 1,000 people ages 15-64 in Jordan in 2008 to that in 2011?
Provide a succinct answer. 0.83. What is the ratio of the new registrations per 1,000 people ages 15-64 in Namibia in 2008 to that in 2011?
Keep it short and to the point. 1.28. What is the ratio of the new registrations per 1,000 people ages 15-64 of Russian Federation in 2008 to that in 2011?
Your answer should be very brief. 1.27. What is the ratio of the new registrations per 1,000 people ages 15-64 in Jordan in 2008 to that in 2012?
Your answer should be compact. 0.67. What is the ratio of the new registrations per 1,000 people ages 15-64 in Namibia in 2008 to that in 2012?
Provide a succinct answer. 1.02. What is the ratio of the new registrations per 1,000 people ages 15-64 in Russian Federation in 2008 to that in 2012?
Your answer should be very brief. 1.32. What is the ratio of the new registrations per 1,000 people ages 15-64 of Jordan in 2009 to that in 2010?
Give a very brief answer. 0.91. What is the ratio of the new registrations per 1,000 people ages 15-64 in Namibia in 2009 to that in 2010?
Give a very brief answer. 1.19. What is the ratio of the new registrations per 1,000 people ages 15-64 in Russian Federation in 2009 to that in 2010?
Offer a very short reply. 1.01. What is the ratio of the new registrations per 1,000 people ages 15-64 in Jordan in 2009 to that in 2011?
Your answer should be very brief. 0.95. What is the ratio of the new registrations per 1,000 people ages 15-64 in Namibia in 2009 to that in 2011?
Provide a succinct answer. 1.12. What is the ratio of the new registrations per 1,000 people ages 15-64 in Russian Federation in 2009 to that in 2011?
Offer a terse response. 0.88. What is the ratio of the new registrations per 1,000 people ages 15-64 of Jordan in 2009 to that in 2012?
Ensure brevity in your answer.  0.77. What is the ratio of the new registrations per 1,000 people ages 15-64 of Namibia in 2009 to that in 2012?
Ensure brevity in your answer.  0.89. What is the ratio of the new registrations per 1,000 people ages 15-64 of Russian Federation in 2009 to that in 2012?
Offer a terse response. 0.91. What is the ratio of the new registrations per 1,000 people ages 15-64 of Jordan in 2010 to that in 2011?
Give a very brief answer. 1.05. What is the ratio of the new registrations per 1,000 people ages 15-64 of Namibia in 2010 to that in 2011?
Your answer should be compact. 0.94. What is the ratio of the new registrations per 1,000 people ages 15-64 of Russian Federation in 2010 to that in 2011?
Give a very brief answer. 0.87. What is the ratio of the new registrations per 1,000 people ages 15-64 in Jordan in 2010 to that in 2012?
Your response must be concise. 0.85. What is the ratio of the new registrations per 1,000 people ages 15-64 in Namibia in 2010 to that in 2012?
Offer a very short reply. 0.75. What is the ratio of the new registrations per 1,000 people ages 15-64 in Russian Federation in 2010 to that in 2012?
Your answer should be compact. 0.91. What is the ratio of the new registrations per 1,000 people ages 15-64 in Jordan in 2011 to that in 2012?
Your answer should be very brief. 0.81. What is the ratio of the new registrations per 1,000 people ages 15-64 in Namibia in 2011 to that in 2012?
Offer a terse response. 0.8. What is the ratio of the new registrations per 1,000 people ages 15-64 in Russian Federation in 2011 to that in 2012?
Ensure brevity in your answer.  1.04. What is the difference between the highest and the second highest new registrations per 1,000 people ages 15-64 of Jordan?
Ensure brevity in your answer.  0.15. What is the difference between the highest and the second highest new registrations per 1,000 people ages 15-64 in Namibia?
Make the answer very short. 0.01. What is the difference between the highest and the second highest new registrations per 1,000 people ages 15-64 of Russian Federation?
Keep it short and to the point. 0.08. What is the difference between the highest and the lowest new registrations per 1,000 people ages 15-64 in Jordan?
Keep it short and to the point. 0.42. What is the difference between the highest and the lowest new registrations per 1,000 people ages 15-64 in Namibia?
Offer a terse response. 0.28. What is the difference between the highest and the lowest new registrations per 1,000 people ages 15-64 of Russian Federation?
Offer a very short reply. 1.91. 